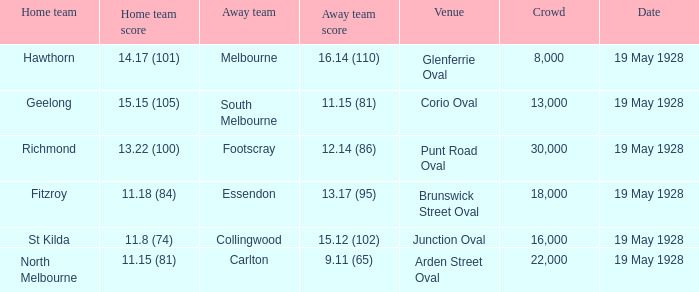What was the official number of attendees at junction oval? 16000.0. 